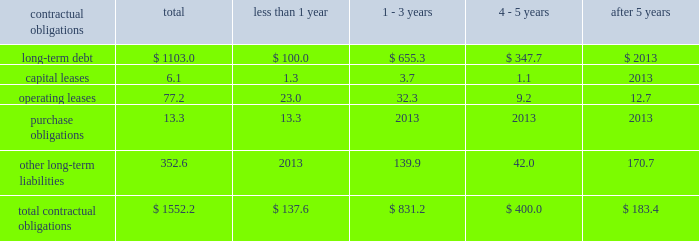Z i m m e r h o l d i n g s , i n c .
A n d s u b s i d i a r i e s 2 0 0 3 f o r m 1 0 - k contractual obligations the company has entered into contracts with various third parties in the normal course of business which will require future payments .
The table illustrates the company 2019s contractual obligations : than 1 - 3 4 - 5 after contractual obligations total 1 year years years 5 years .
Critical accounting estimates the financial results of the company are affected by the income taxes 2013 the company estimates income selection and application of accounting policies and methods .
Tax expense and income tax liabilities and assets by taxable significant accounting policies which require management 2019s jurisdiction .
Realization of deferred tax assets in each taxable judgment are discussed below .
Jurisdiction is dependent on the company 2019s ability to generate future taxable income sufficient to realize the excess inventory and instruments 2013 the company benefits .
The company evaluates deferred tax assets on must determine as of each balance sheet date how much , if an ongoing basis and provides valuation allowances if it is any , of its inventory may ultimately prove to be unsaleable or determined to be 2018 2018more likely than not 2019 2019 that the deferred unsaleable at its carrying cost .
Similarly , the company must tax benefit will not be realized .
Federal income taxes are also determine if instruments on hand will be put to provided on the portion of the income of foreign subsidiaries productive use or remain undeployed as a result of excess that is expected to be remitted to the u.s .
The company supply .
Reserves are established to effectively adjust operates within numerous taxing jurisdictions .
The company inventory and instruments to net realizable value .
To is subject to regulatory review or audit in virtually all of determine the appropriate level of reserves , the company those jurisdictions and those reviews and audits may require evaluates current stock levels in relation to historical and extended periods of time to resolve .
The company makes use expected patterns of demand for all of its products and of all available information and makes reasoned judgments instrument systems and components .
The basis for the regarding matters requiring interpretation in establishing determination is generally the same for all inventory and tax expense , liabilities and reserves .
The company believes instrument items and categories except for work-in-progress adequate provisions exist for income taxes for all periods inventory , which is recorded at cost .
Obsolete or and jurisdictions subject to review or audit .
Discontinued items are generally destroyed and completely written off .
Management evaluates the need for changes to commitments and contingencies 2013 accruals for valuation reserves based on market conditions , competitive product liability and other claims are established with offerings and other factors on a regular basis .
Centerpulse internal and external counsel based on current information historically applied a similar conceptual framework in and historical settlement information for claims , related fees estimating market value of excess inventory and instruments and for claims incurred but not reported .
An actuarial model under international financial reporting standards and is used by the company to assist management in determining u.s .
Generally accepted accounting principles .
Within that an appropriate level of accruals for product liability claims .
Framework , zimmer and centerpulse differed however , in historical patterns of claim loss development over time are certain respects , to their approaches to such estimation .
Statistically analyzed to arrive at factors which are then following the acquisition , the company determined that a applied to loss estimates in the actuarial model .
The amounts consistent approach is necessary to maintaining effective established represent management 2019s best estimate of the control over financial reporting .
Consideration was given to ultimate costs that it will incur under the various both approaches and the company established a common contingencies .
Estimation technique taking both prior approaches into account .
This change in estimate resulted in a charge to earnings of $ 3.0 million after tax in the fourth quarter .
Such change is not considered material to the company 2019s financial position , results of operations or cash flows. .
What percent of total contractual obligations is comprised of long-term debt? 
Computations: (1103.0 / 1552.2)
Answer: 0.7106. 